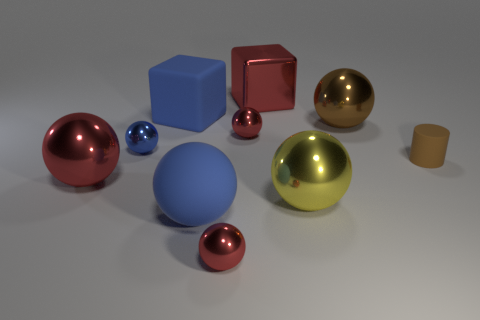Subtract all purple blocks. How many red spheres are left? 3 Subtract all tiny blue balls. How many balls are left? 6 Subtract 4 spheres. How many spheres are left? 3 Subtract all brown balls. How many balls are left? 6 Subtract all red spheres. Subtract all cyan cylinders. How many spheres are left? 4 Subtract all cubes. How many objects are left? 8 Subtract all yellow metallic balls. Subtract all tiny brown objects. How many objects are left? 8 Add 4 brown rubber objects. How many brown rubber objects are left? 5 Add 8 large cyan rubber objects. How many large cyan rubber objects exist? 8 Subtract 0 brown blocks. How many objects are left? 10 